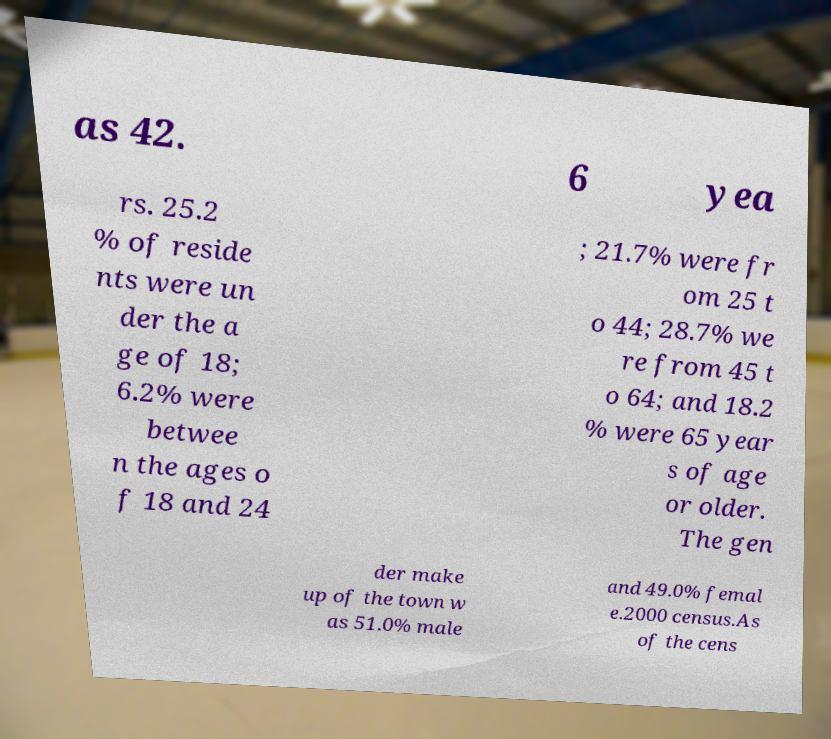There's text embedded in this image that I need extracted. Can you transcribe it verbatim? as 42. 6 yea rs. 25.2 % of reside nts were un der the a ge of 18; 6.2% were betwee n the ages o f 18 and 24 ; 21.7% were fr om 25 t o 44; 28.7% we re from 45 t o 64; and 18.2 % were 65 year s of age or older. The gen der make up of the town w as 51.0% male and 49.0% femal e.2000 census.As of the cens 